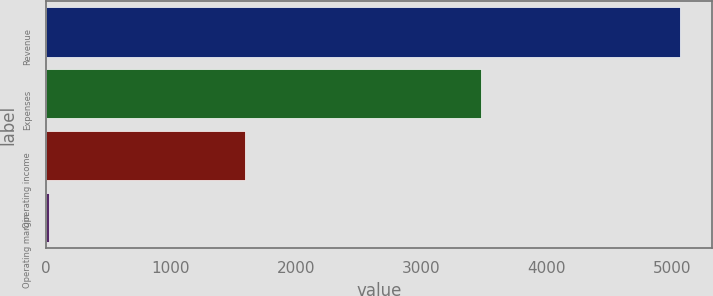<chart> <loc_0><loc_0><loc_500><loc_500><bar_chart><fcel>Revenue<fcel>Expenses<fcel>Operating income<fcel>Operating margin<nl><fcel>5064<fcel>3471<fcel>1593<fcel>31.5<nl></chart> 